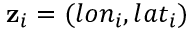<formula> <loc_0><loc_0><loc_500><loc_500>z _ { i } = ( l o n _ { i } , l a t _ { i } )</formula> 